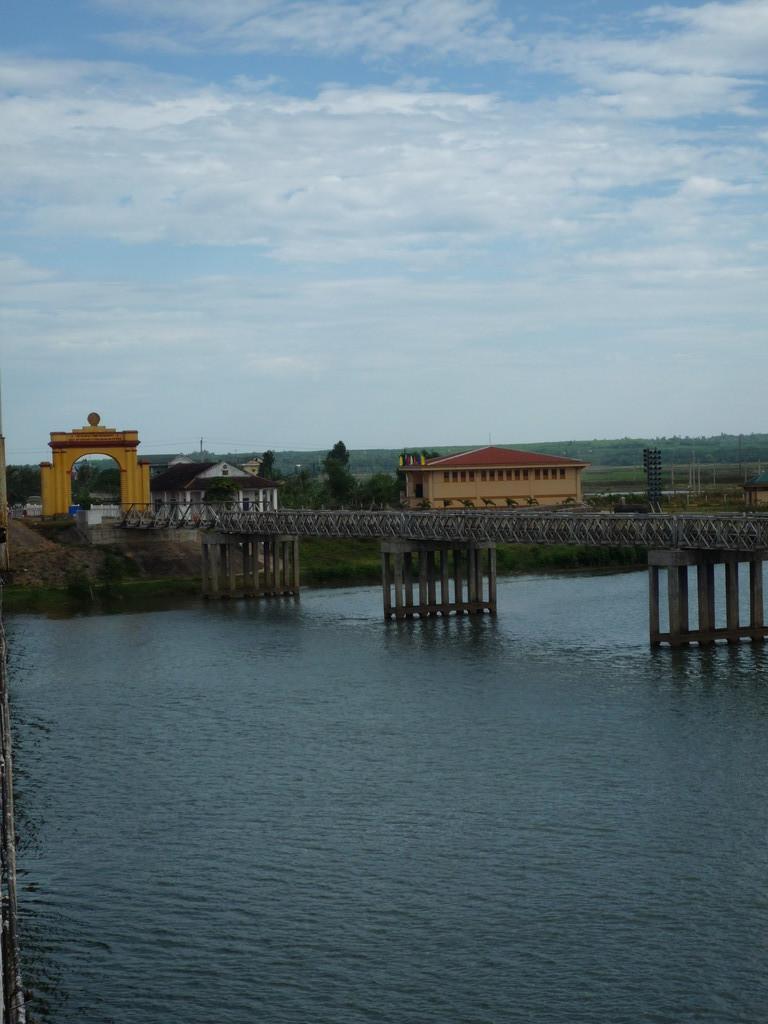Please provide a concise description of this image. In the image we can see sky on the top and one bridge. Behind the bridge there is a house with red color rooftop. Beside the house there is one tree and water below the bridge. 